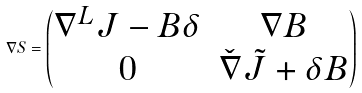Convert formula to latex. <formula><loc_0><loc_0><loc_500><loc_500>\nabla S = \begin{pmatrix} \nabla ^ { L } J - B \delta & \nabla B \\ 0 & \check { \nabla } \tilde { J } + \delta B \end{pmatrix}</formula> 